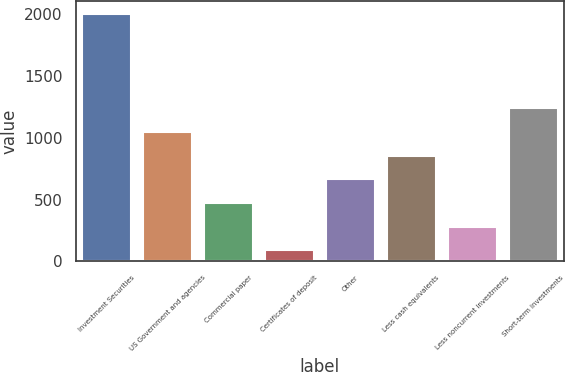Convert chart. <chart><loc_0><loc_0><loc_500><loc_500><bar_chart><fcel>Investment Securities<fcel>US Government and agencies<fcel>Commercial paper<fcel>Certificates of deposit<fcel>Other<fcel>Less cash equivalents<fcel>Less noncurrent investments<fcel>Short-term investments<nl><fcel>2002<fcel>1046.05<fcel>472.48<fcel>90.1<fcel>663.67<fcel>854.86<fcel>281.29<fcel>1237.24<nl></chart> 